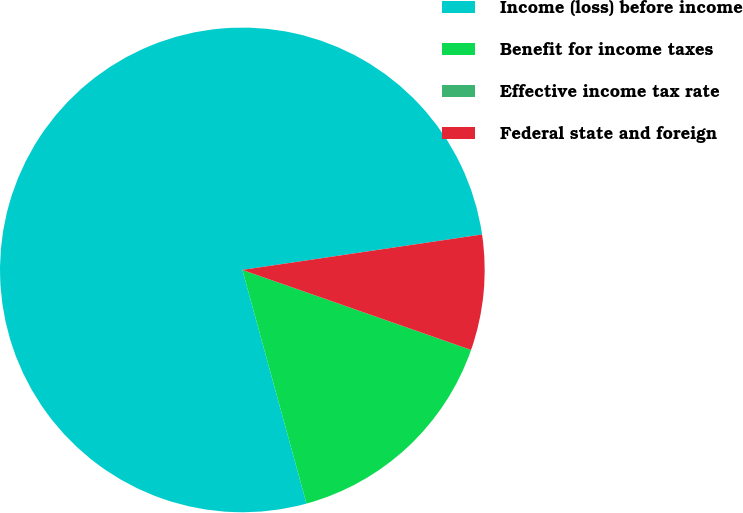Convert chart. <chart><loc_0><loc_0><loc_500><loc_500><pie_chart><fcel>Income (loss) before income<fcel>Benefit for income taxes<fcel>Effective income tax rate<fcel>Federal state and foreign<nl><fcel>76.92%<fcel>15.38%<fcel>0.0%<fcel>7.69%<nl></chart> 